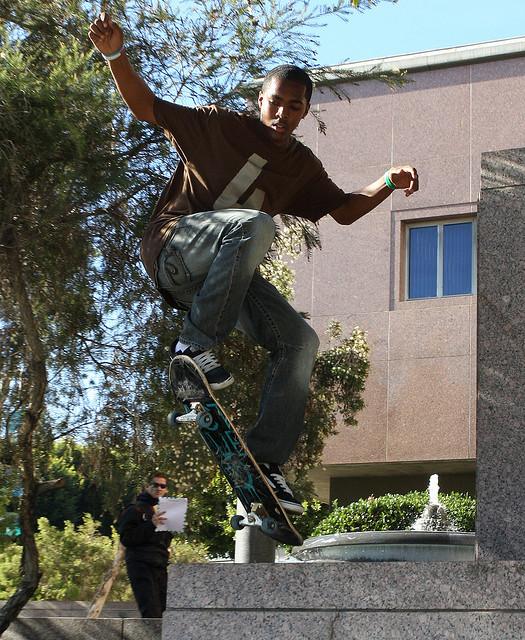What is the man wearing on his wrist?
Short answer required. Watch. Is the picture colored?
Quick response, please. Yes. What is the boy doing?
Answer briefly. Skateboarding. What kind of shoes is the person wearing?
Concise answer only. Sneakers. Is the person in the background wearing sunglasses?
Short answer required. Yes. 